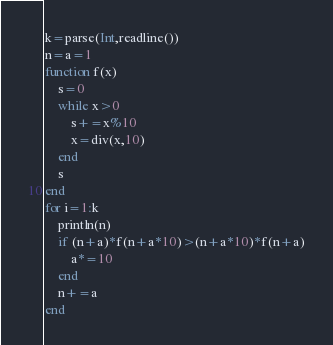Convert code to text. <code><loc_0><loc_0><loc_500><loc_500><_Julia_>k=parse(Int,readline())
n=a=1
function f(x)
	s=0
	while x>0
		s+=x%10
		x=div(x,10)
	end
	s
end
for i=1:k
	println(n)
	if (n+a)*f(n+a*10)>(n+a*10)*f(n+a)
		a*=10
	end
	n+=a
end</code> 